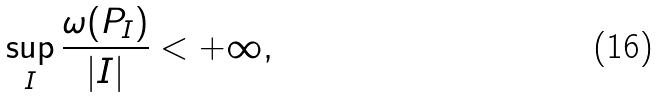<formula> <loc_0><loc_0><loc_500><loc_500>\sup _ { I } \frac { \omega ( P _ { I } ) } { | I | } < + \infty ,</formula> 